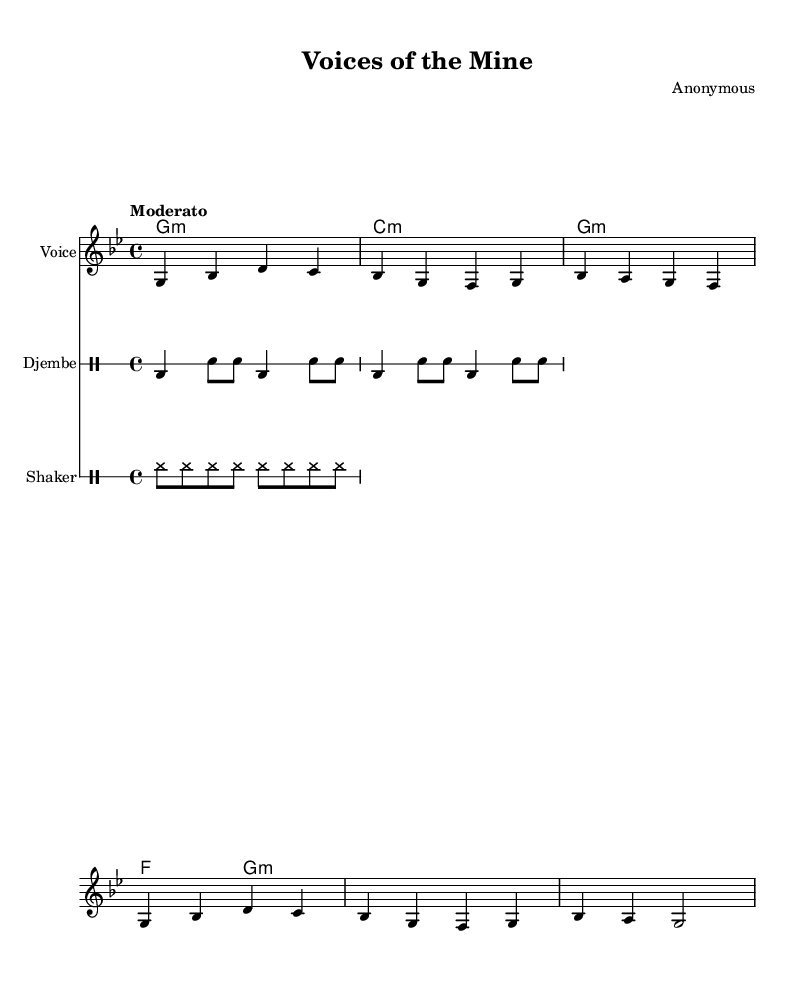What is the key signature of this music? The key signature is G minor, which has two flats (B flat and E flat). We can ascertain this by looking at the key signature indicated at the beginning of the staff, where G minor is identified with two flat signs.
Answer: G minor What is the time signature of this music? The time signature is 4/4, indicated by the numbers at the beginning of the staff. This means there are four beats in a measure and a quarter note gets one beat.
Answer: 4/4 What is the tempo indication for this piece? The tempo is marked as "Moderato," which instructs the performer to play at a moderate speed. This term is usually understood in a general context in music terminology.
Answer: Moderato How many measures are there in the voice part? There are four measures in the voice part. By counting the vertical bar lines (which indicate the end of each measure), we can determine the total number of measures present.
Answer: 4 What type of song is this, based on its themes? This is a protest song addressing labor rights and community solidarity, as highlighted in the lyrics which discuss unity, labor, and miners’ rights. This thematic representation is common in African protest music, where similar subjects are often addressed.
Answer: Protest song What instruments are featured in this piece aside from the voice? The piece features a djembe and a shaker as the accompanying instruments alongside the voice, as indicated by their respective drum staff sections labeled at the beginning.
Answer: Djembe and shaker What do the lyrics convey about the community? The lyrics convey a strong message of unity and determination among miners and their families in the fight for their rights, emphasizing collective effort and support within the community. This reflects the broader themes often found in African protest songs.
Answer: Unity and determination 